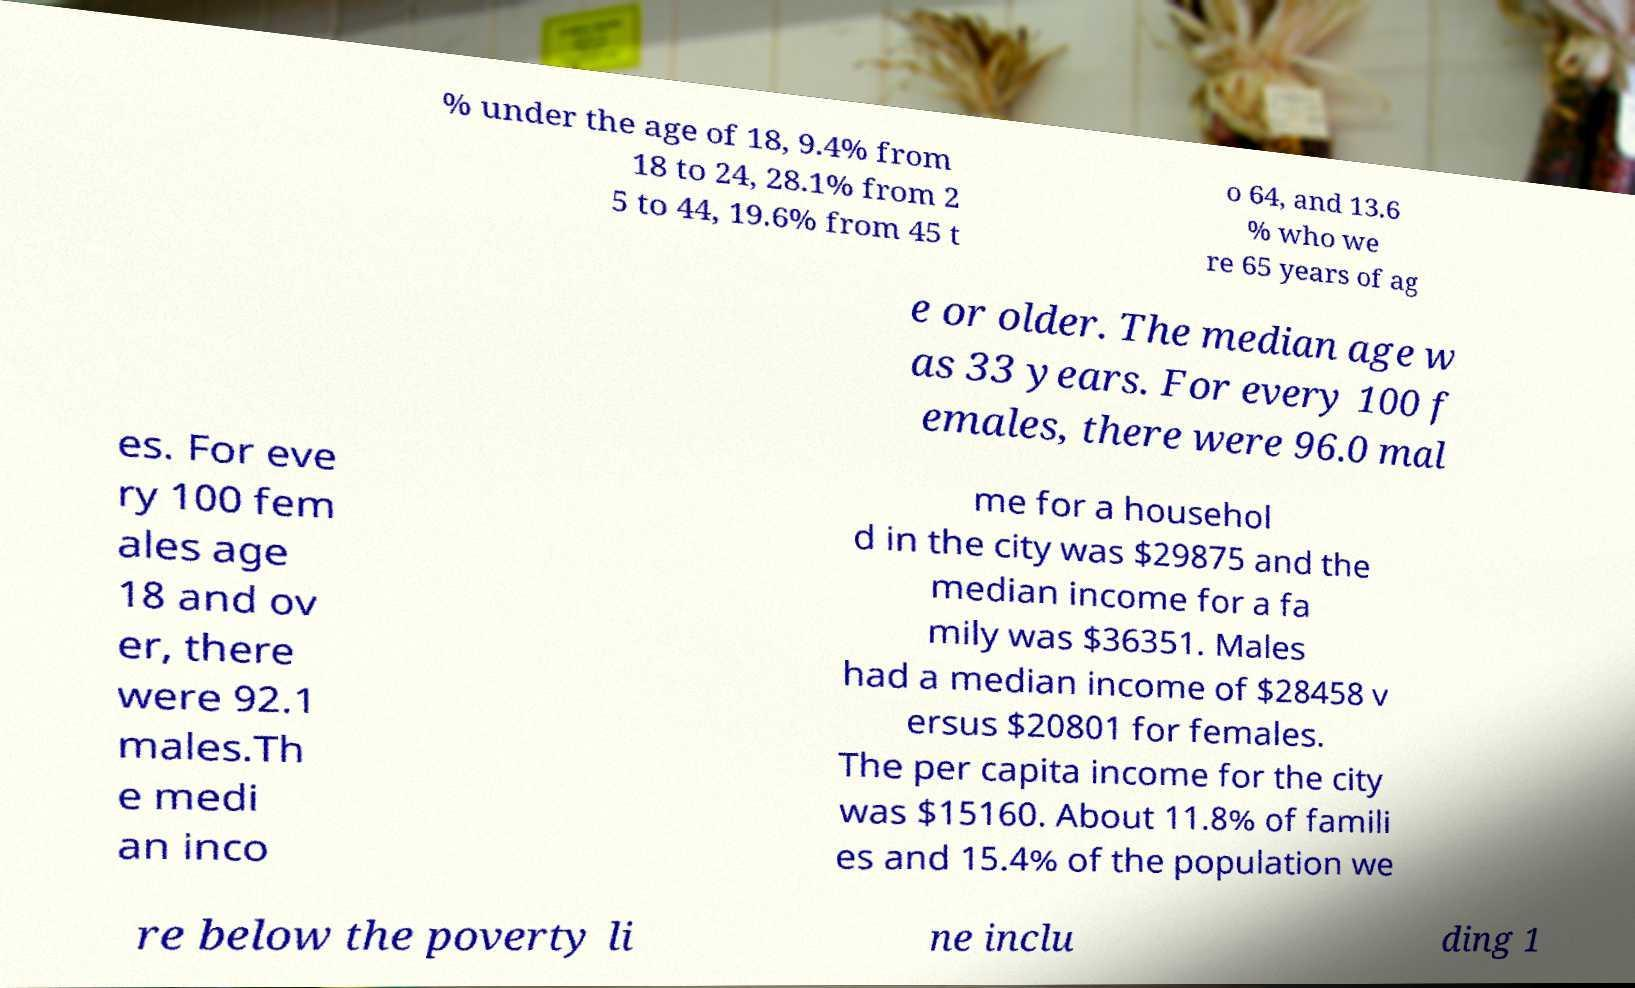For documentation purposes, I need the text within this image transcribed. Could you provide that? % under the age of 18, 9.4% from 18 to 24, 28.1% from 2 5 to 44, 19.6% from 45 t o 64, and 13.6 % who we re 65 years of ag e or older. The median age w as 33 years. For every 100 f emales, there were 96.0 mal es. For eve ry 100 fem ales age 18 and ov er, there were 92.1 males.Th e medi an inco me for a househol d in the city was $29875 and the median income for a fa mily was $36351. Males had a median income of $28458 v ersus $20801 for females. The per capita income for the city was $15160. About 11.8% of famili es and 15.4% of the population we re below the poverty li ne inclu ding 1 